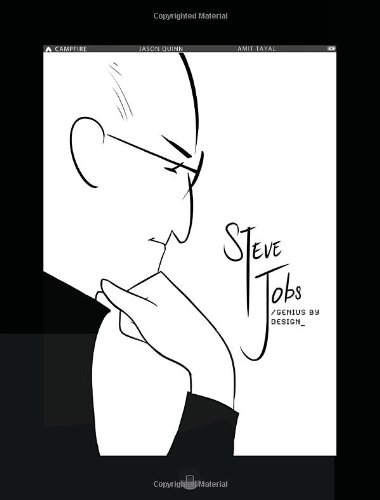Who wrote this book? The book 'Steve Jobs: Genius by Design' is authored by Jason Quinn, known for his engaging graphical biographies. 